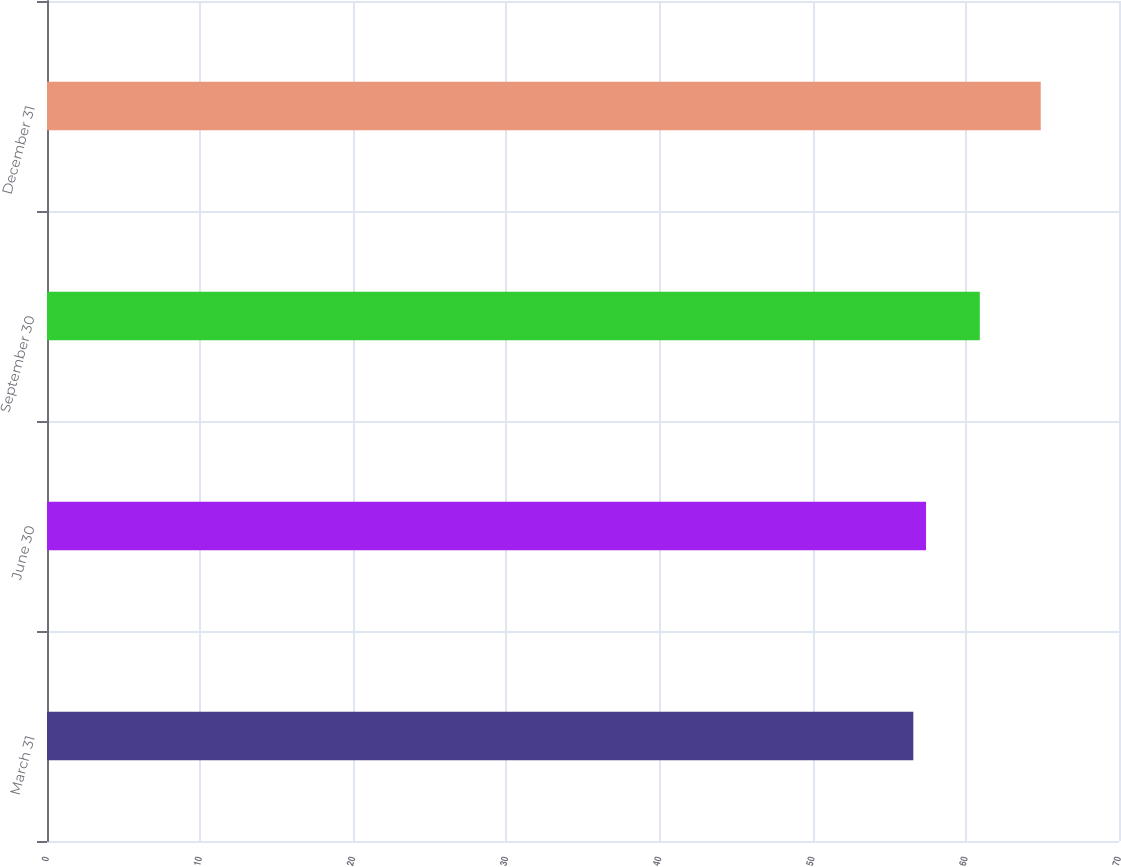Convert chart to OTSL. <chart><loc_0><loc_0><loc_500><loc_500><bar_chart><fcel>March 31<fcel>June 30<fcel>September 30<fcel>December 31<nl><fcel>56.57<fcel>57.4<fcel>60.91<fcel>64.89<nl></chart> 